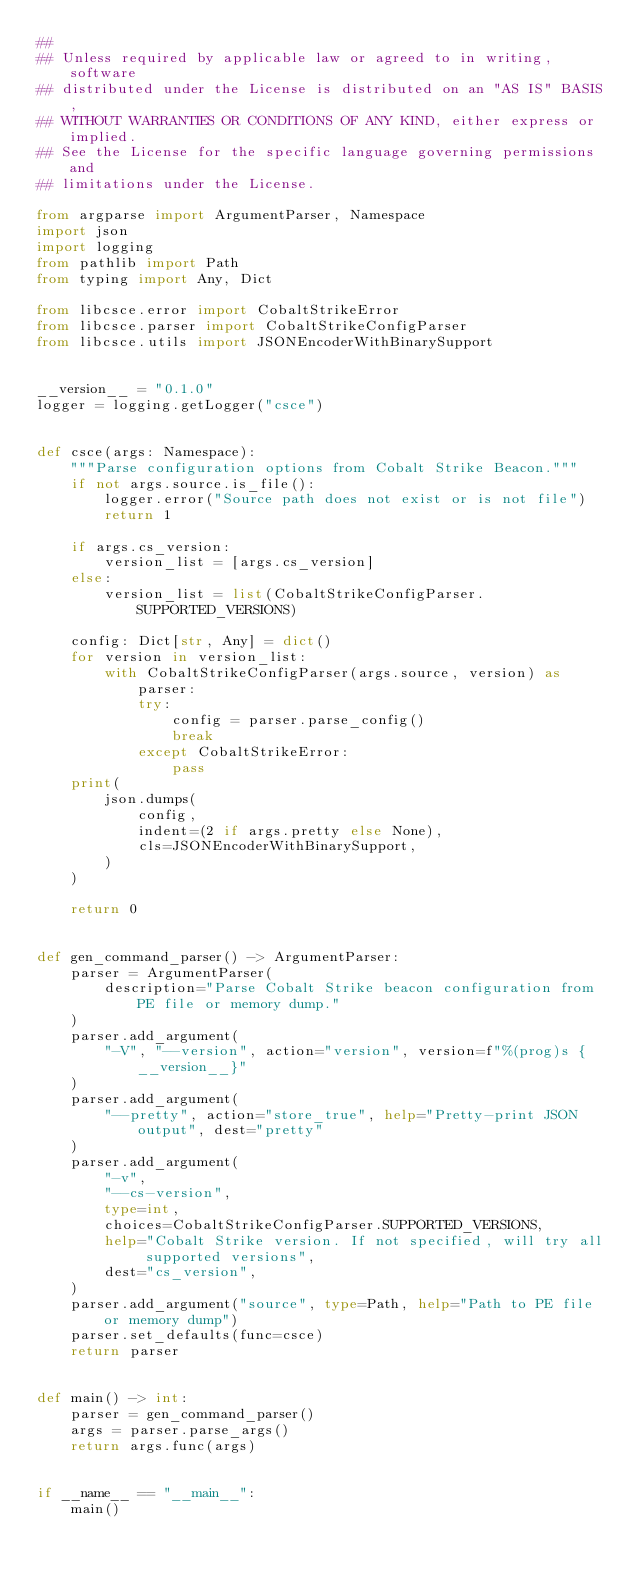Convert code to text. <code><loc_0><loc_0><loc_500><loc_500><_Python_>##
## Unless required by applicable law or agreed to in writing, software
## distributed under the License is distributed on an "AS IS" BASIS,
## WITHOUT WARRANTIES OR CONDITIONS OF ANY KIND, either express or implied.
## See the License for the specific language governing permissions and
## limitations under the License.

from argparse import ArgumentParser, Namespace
import json
import logging
from pathlib import Path
from typing import Any, Dict

from libcsce.error import CobaltStrikeError
from libcsce.parser import CobaltStrikeConfigParser
from libcsce.utils import JSONEncoderWithBinarySupport


__version__ = "0.1.0"
logger = logging.getLogger("csce")


def csce(args: Namespace):
    """Parse configuration options from Cobalt Strike Beacon."""
    if not args.source.is_file():
        logger.error("Source path does not exist or is not file")
        return 1

    if args.cs_version:
        version_list = [args.cs_version]
    else:
        version_list = list(CobaltStrikeConfigParser.SUPPORTED_VERSIONS)

    config: Dict[str, Any] = dict()
    for version in version_list:
        with CobaltStrikeConfigParser(args.source, version) as parser:
            try:
                config = parser.parse_config()
                break
            except CobaltStrikeError:
                pass
    print(
        json.dumps(
            config,
            indent=(2 if args.pretty else None),
            cls=JSONEncoderWithBinarySupport,
        )
    )

    return 0


def gen_command_parser() -> ArgumentParser:
    parser = ArgumentParser(
        description="Parse Cobalt Strike beacon configuration from PE file or memory dump."
    )
    parser.add_argument(
        "-V", "--version", action="version", version=f"%(prog)s {__version__}"
    )
    parser.add_argument(
        "--pretty", action="store_true", help="Pretty-print JSON output", dest="pretty"
    )
    parser.add_argument(
        "-v",
        "--cs-version",
        type=int,
        choices=CobaltStrikeConfigParser.SUPPORTED_VERSIONS,
        help="Cobalt Strike version. If not specified, will try all supported versions",
        dest="cs_version",
    )
    parser.add_argument("source", type=Path, help="Path to PE file or memory dump")
    parser.set_defaults(func=csce)
    return parser


def main() -> int:
    parser = gen_command_parser()
    args = parser.parse_args()
    return args.func(args)


if __name__ == "__main__":
    main()
</code> 